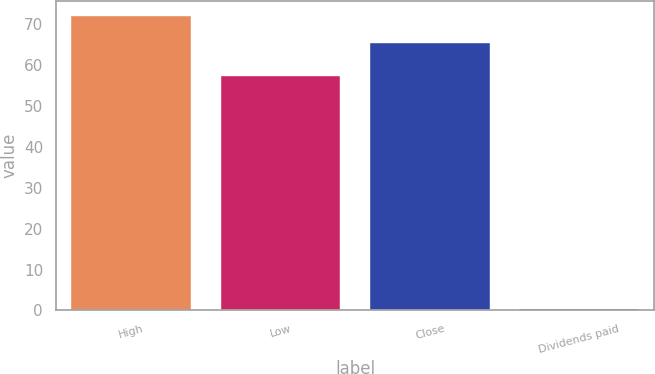<chart> <loc_0><loc_0><loc_500><loc_500><bar_chart><fcel>High<fcel>Low<fcel>Close<fcel>Dividends paid<nl><fcel>72.14<fcel>57.38<fcel>65.52<fcel>0.25<nl></chart> 